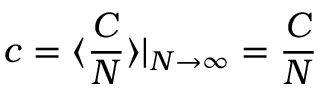<formula> <loc_0><loc_0><loc_500><loc_500>c = \langle \frac { C } { N } \rangle | _ { N \to \infty } = \frac { C } { N }</formula> 